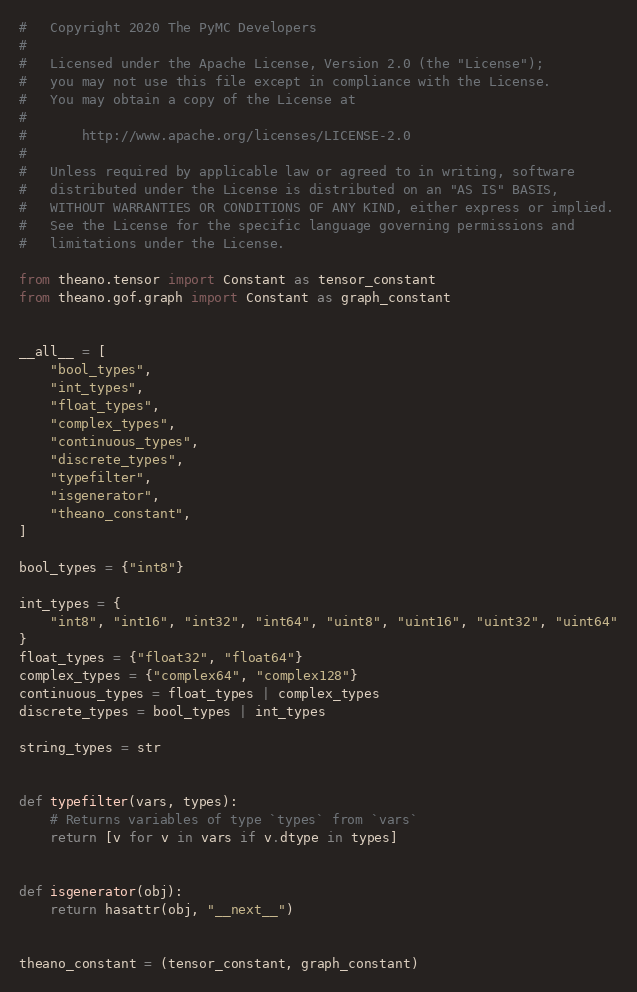<code> <loc_0><loc_0><loc_500><loc_500><_Python_>#   Copyright 2020 The PyMC Developers
#
#   Licensed under the Apache License, Version 2.0 (the "License");
#   you may not use this file except in compliance with the License.
#   You may obtain a copy of the License at
#
#       http://www.apache.org/licenses/LICENSE-2.0
#
#   Unless required by applicable law or agreed to in writing, software
#   distributed under the License is distributed on an "AS IS" BASIS,
#   WITHOUT WARRANTIES OR CONDITIONS OF ANY KIND, either express or implied.
#   See the License for the specific language governing permissions and
#   limitations under the License.

from theano.tensor import Constant as tensor_constant
from theano.gof.graph import Constant as graph_constant


__all__ = [
    "bool_types",
    "int_types",
    "float_types",
    "complex_types",
    "continuous_types",
    "discrete_types",
    "typefilter",
    "isgenerator",
    "theano_constant",
]

bool_types = {"int8"}

int_types = {
    "int8", "int16", "int32", "int64", "uint8", "uint16", "uint32", "uint64"
}
float_types = {"float32", "float64"}
complex_types = {"complex64", "complex128"}
continuous_types = float_types | complex_types
discrete_types = bool_types | int_types

string_types = str


def typefilter(vars, types):
    # Returns variables of type `types` from `vars`
    return [v for v in vars if v.dtype in types]


def isgenerator(obj):
    return hasattr(obj, "__next__")


theano_constant = (tensor_constant, graph_constant)
</code> 